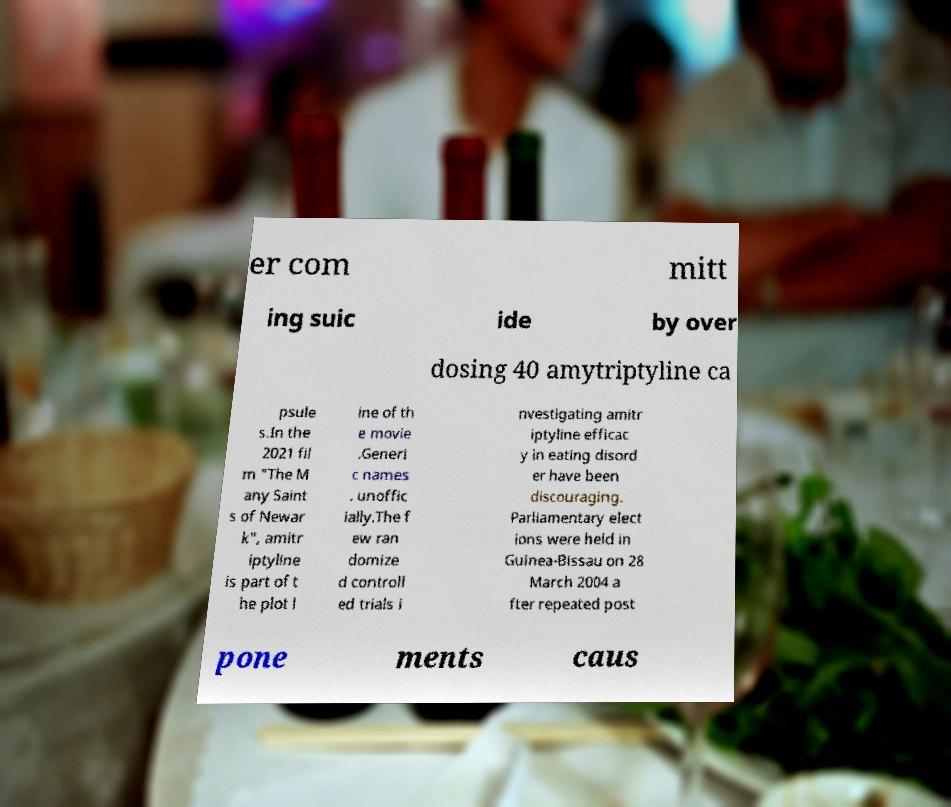There's text embedded in this image that I need extracted. Can you transcribe it verbatim? er com mitt ing suic ide by over dosing 40 amytriptyline ca psule s.In the 2021 fil m "The M any Saint s of Newar k", amitr iptyline is part of t he plot l ine of th e movie .Generi c names . unoffic ially.The f ew ran domize d controll ed trials i nvestigating amitr iptyline efficac y in eating disord er have been discouraging. Parliamentary elect ions were held in Guinea-Bissau on 28 March 2004 a fter repeated post pone ments caus 